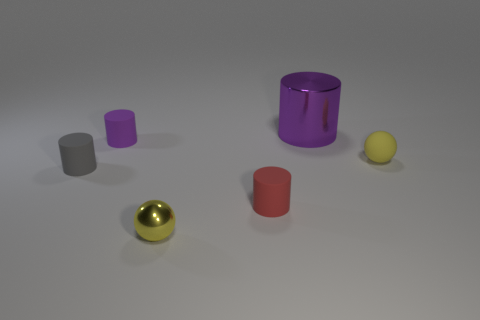There is a tiny thing that is on the right side of the red rubber object; is its color the same as the small sphere that is in front of the tiny red rubber object?
Give a very brief answer. Yes. What shape is the shiny object that is the same color as the small matte sphere?
Provide a short and direct response. Sphere. What number of shiny objects are tiny purple balls or small red cylinders?
Give a very brief answer. 0. The rubber object that is in front of the thing left of the purple cylinder left of the big purple thing is what color?
Give a very brief answer. Red. The metal thing that is the same shape as the tiny gray rubber thing is what color?
Your answer should be compact. Purple. How many other things are made of the same material as the tiny red thing?
Offer a terse response. 3. What is the size of the metal ball?
Your answer should be compact. Small. Is there a small yellow rubber thing that has the same shape as the big metallic thing?
Offer a very short reply. No. What number of objects are tiny metallic things or gray rubber objects that are on the left side of the large metal thing?
Offer a terse response. 2. What color is the metallic object that is behind the red object?
Keep it short and to the point. Purple. 